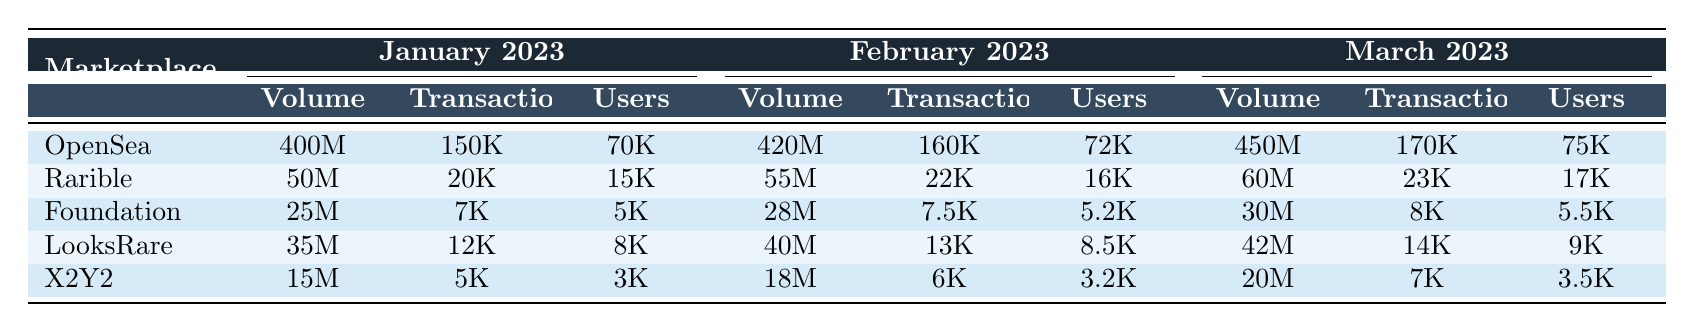What was the trading volume of OpenSea in February 2023? From the table, under the February 2023 section for OpenSea, the trading volume is listed as "420 million."
Answer: 420 million How many active users did Rarible have in January 2023? Referring to the January 2023 section for Rarible, the number of active users is given as "15000."
Answer: 15000 In March 2023, which marketplace had the highest trading volume, and what was that volume? By comparing the trading volumes for March 2023, OpenSea has "450 million," Rarible has "60 million," Foundation has "30 million," LooksRare has "42 million," and X2Y2 has "20 million." The highest volume is OpenSea at 450 million.
Answer: OpenSea, 450 million What was the percentage increase in trading volume for Foundation from January to March 2023? Foundation’s trading volume in January is "25 million" and in March is "30 million." The increase is calculated as (30M - 25M) / 25M * 100%, which is 20%.
Answer: 20% True or false: LooksRare had more active users in March than Foundation had in the same month. In March 2023, LooksRare had "9000" active users, while Foundation had "5500." Since 9000 > 5500, the statement is true.
Answer: True Determine the average trading volume across all marketplaces in February 2023. The trading volumes for February are: OpenSea (420M), Rarible (55M), Foundation (28M), LooksRare (40M), and X2Y2 (18M). So, the total volume is 420 + 55 + 28 + 40 + 18 = 561 million. Dividing by 5 gives an average of 561M / 5 = 112.2 million.
Answer: 112.2 million Which marketplace saw the smallest number of transactions in January 2023? Looking at the transactions for January, OpenSea has "150K," Rarible has "20K," Foundation has "7K," LooksRare has "12K," and X2Y2 has "5K." The smallest is X2Y2 with "5K."
Answer: X2Y2 Calculate the total number of active users for all marketplaces combined in March 2023. The active users in March for each marketplace are: OpenSea (75K), Rarible (17K), Foundation (5.5K), LooksRare (9K), and X2Y2 (3.5K). Adding them gives: 75 + 17 + 5.5 + 9 + 3.5 = 110 million.
Answer: 110K 